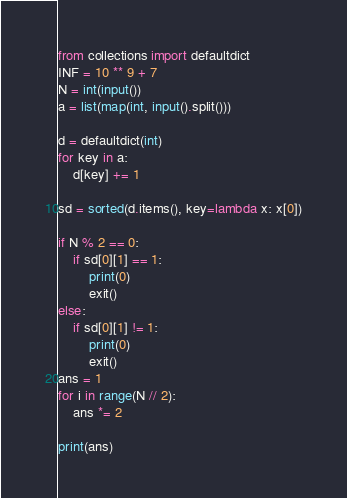<code> <loc_0><loc_0><loc_500><loc_500><_Python_>from collections import defaultdict
INF = 10 ** 9 + 7
N = int(input())
a = list(map(int, input().split()))

d = defaultdict(int)
for key in a:
    d[key] += 1

sd = sorted(d.items(), key=lambda x: x[0])

if N % 2 == 0:
    if sd[0][1] == 1:
        print(0)
        exit()
else:
    if sd[0][1] != 1:
        print(0)
        exit()
ans = 1
for i in range(N // 2):
    ans *= 2

print(ans)</code> 